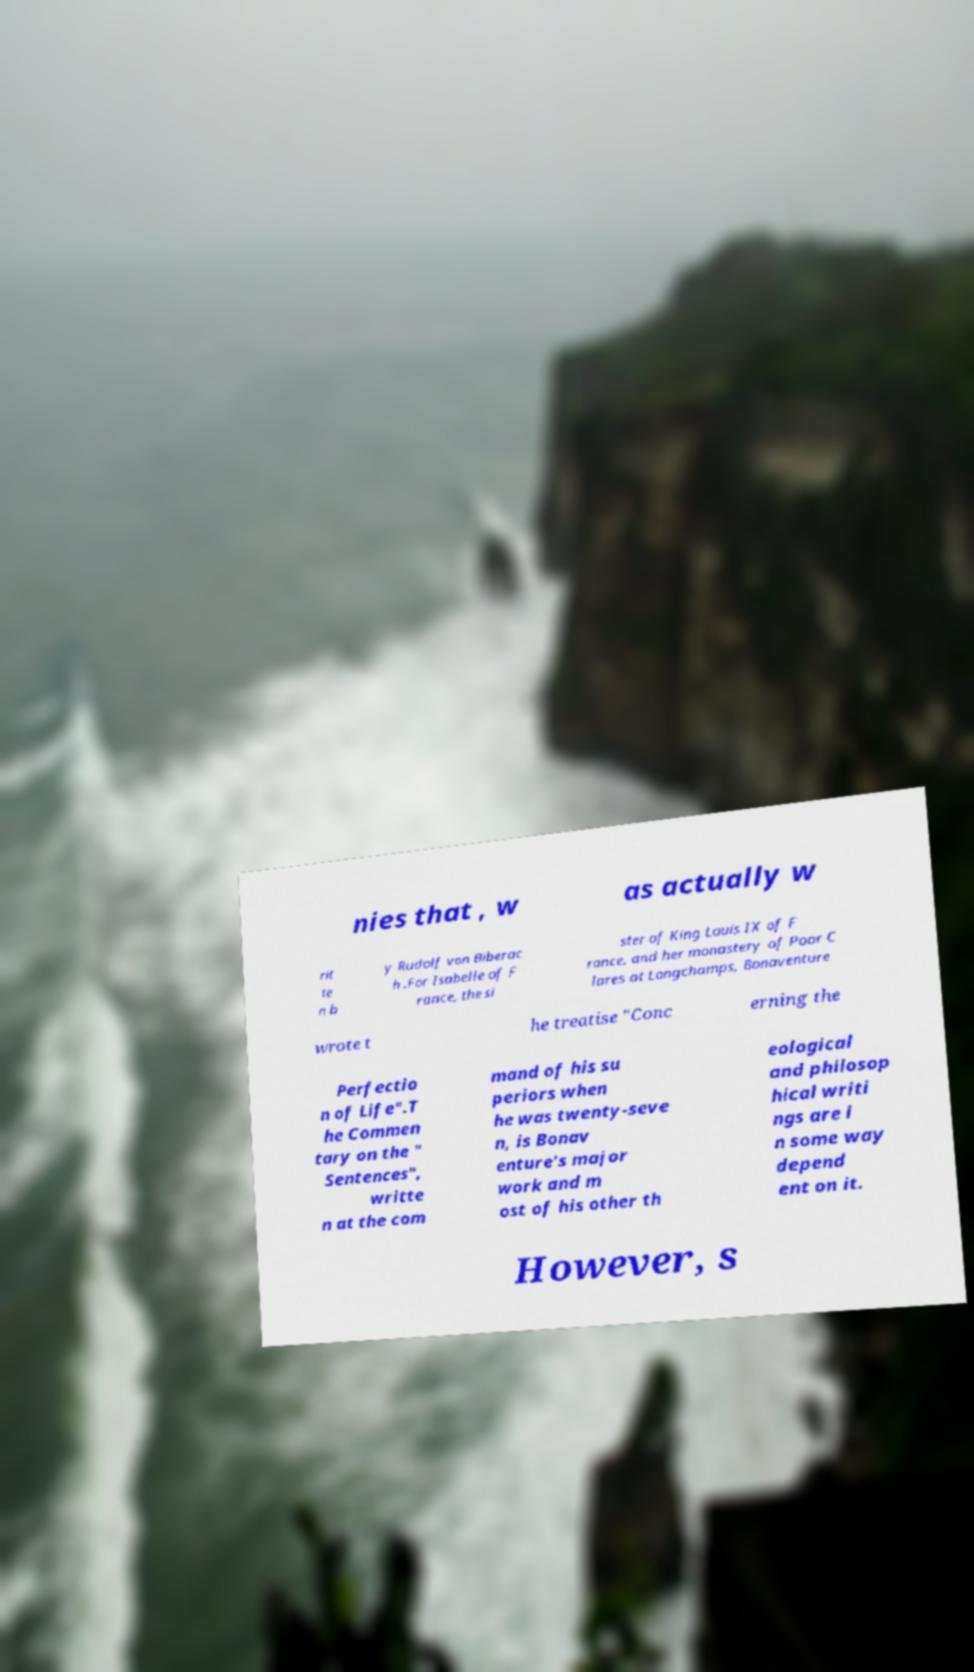Could you extract and type out the text from this image? nies that , w as actually w rit te n b y Rudolf von Biberac h .For Isabelle of F rance, the si ster of King Louis IX of F rance, and her monastery of Poor C lares at Longchamps, Bonaventure wrote t he treatise "Conc erning the Perfectio n of Life".T he Commen tary on the " Sentences", writte n at the com mand of his su periors when he was twenty-seve n, is Bonav enture's major work and m ost of his other th eological and philosop hical writi ngs are i n some way depend ent on it. However, s 